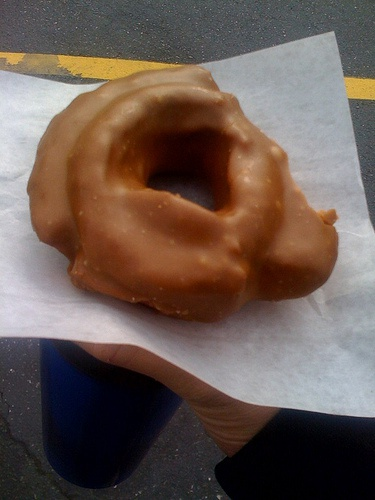Describe the objects in this image and their specific colors. I can see donut in black, maroon, brown, and gray tones, people in black, maroon, and brown tones, and cup in black, navy, and gray tones in this image. 